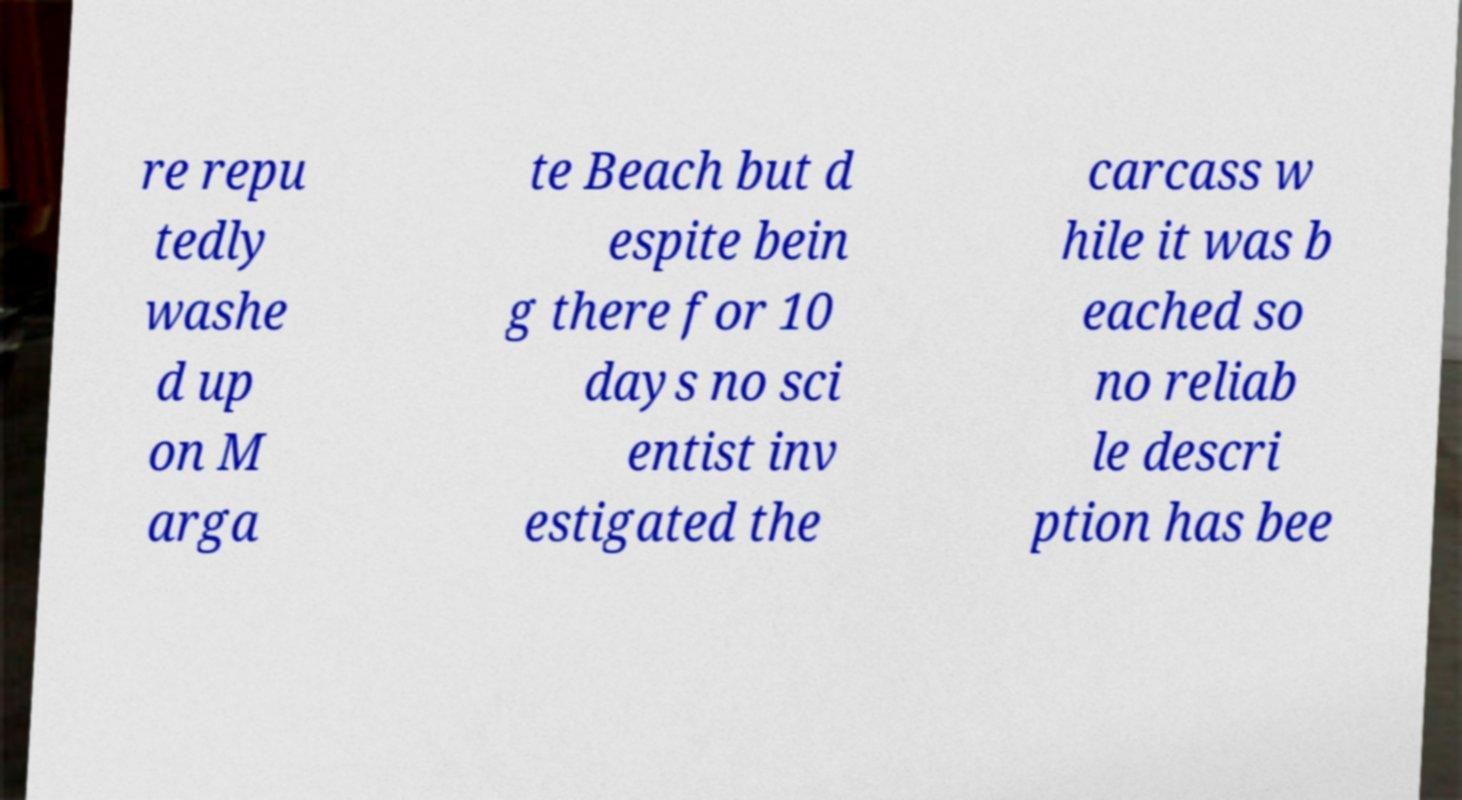Can you read and provide the text displayed in the image?This photo seems to have some interesting text. Can you extract and type it out for me? re repu tedly washe d up on M arga te Beach but d espite bein g there for 10 days no sci entist inv estigated the carcass w hile it was b eached so no reliab le descri ption has bee 